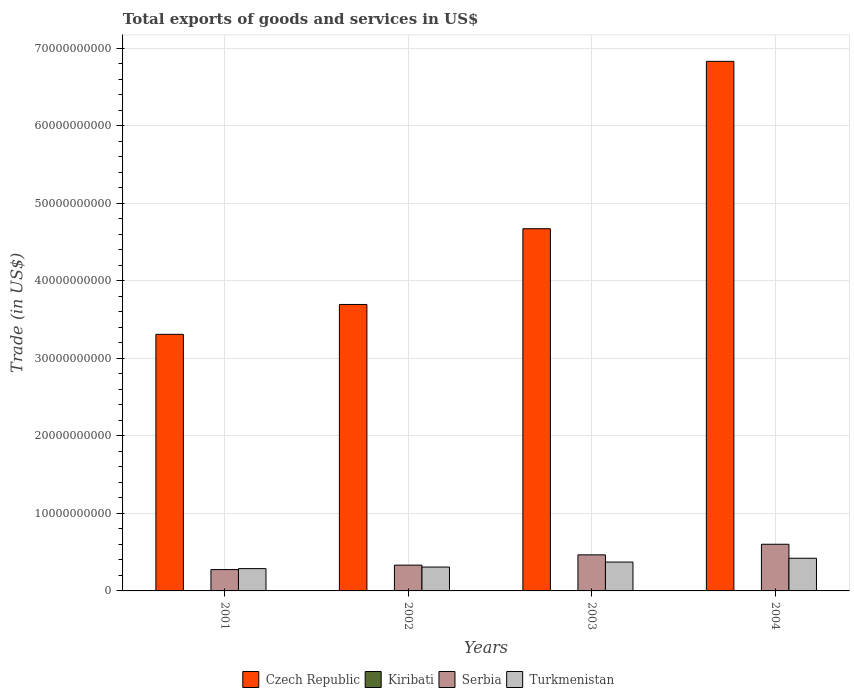Are the number of bars per tick equal to the number of legend labels?
Provide a short and direct response. Yes. How many bars are there on the 3rd tick from the left?
Your response must be concise. 4. How many bars are there on the 4th tick from the right?
Your response must be concise. 4. What is the label of the 1st group of bars from the left?
Make the answer very short. 2001. What is the total exports of goods and services in Czech Republic in 2003?
Provide a succinct answer. 4.67e+1. Across all years, what is the maximum total exports of goods and services in Czech Republic?
Provide a short and direct response. 6.83e+1. Across all years, what is the minimum total exports of goods and services in Serbia?
Give a very brief answer. 2.75e+09. In which year was the total exports of goods and services in Turkmenistan maximum?
Your response must be concise. 2004. In which year was the total exports of goods and services in Serbia minimum?
Offer a terse response. 2001. What is the total total exports of goods and services in Turkmenistan in the graph?
Offer a terse response. 1.39e+1. What is the difference between the total exports of goods and services in Serbia in 2002 and that in 2003?
Your response must be concise. -1.33e+09. What is the difference between the total exports of goods and services in Czech Republic in 2003 and the total exports of goods and services in Serbia in 2002?
Give a very brief answer. 4.34e+1. What is the average total exports of goods and services in Turkmenistan per year?
Provide a short and direct response. 3.47e+09. In the year 2004, what is the difference between the total exports of goods and services in Serbia and total exports of goods and services in Czech Republic?
Your answer should be compact. -6.23e+1. In how many years, is the total exports of goods and services in Turkmenistan greater than 32000000000 US$?
Provide a short and direct response. 0. What is the ratio of the total exports of goods and services in Turkmenistan in 2002 to that in 2004?
Offer a terse response. 0.73. What is the difference between the highest and the second highest total exports of goods and services in Czech Republic?
Your response must be concise. 2.16e+1. What is the difference between the highest and the lowest total exports of goods and services in Kiribati?
Your answer should be very brief. 4.78e+06. Is it the case that in every year, the sum of the total exports of goods and services in Czech Republic and total exports of goods and services in Turkmenistan is greater than the sum of total exports of goods and services in Serbia and total exports of goods and services in Kiribati?
Offer a terse response. No. What does the 2nd bar from the left in 2004 represents?
Your answer should be compact. Kiribati. What does the 3rd bar from the right in 2001 represents?
Offer a terse response. Kiribati. Is it the case that in every year, the sum of the total exports of goods and services in Turkmenistan and total exports of goods and services in Kiribati is greater than the total exports of goods and services in Serbia?
Offer a very short reply. No. How many bars are there?
Provide a succinct answer. 16. Are all the bars in the graph horizontal?
Offer a terse response. No. How many years are there in the graph?
Offer a very short reply. 4. What is the difference between two consecutive major ticks on the Y-axis?
Ensure brevity in your answer.  1.00e+1. Are the values on the major ticks of Y-axis written in scientific E-notation?
Offer a very short reply. No. Does the graph contain any zero values?
Your answer should be compact. No. How many legend labels are there?
Ensure brevity in your answer.  4. How are the legend labels stacked?
Offer a terse response. Horizontal. What is the title of the graph?
Your answer should be very brief. Total exports of goods and services in US$. What is the label or title of the X-axis?
Your answer should be compact. Years. What is the label or title of the Y-axis?
Provide a succinct answer. Trade (in US$). What is the Trade (in US$) of Czech Republic in 2001?
Ensure brevity in your answer.  3.31e+1. What is the Trade (in US$) of Kiribati in 2001?
Your answer should be compact. 1.01e+07. What is the Trade (in US$) of Serbia in 2001?
Ensure brevity in your answer.  2.75e+09. What is the Trade (in US$) in Turkmenistan in 2001?
Provide a succinct answer. 2.88e+09. What is the Trade (in US$) in Czech Republic in 2002?
Provide a succinct answer. 3.70e+1. What is the Trade (in US$) of Kiribati in 2002?
Your answer should be compact. 1.35e+07. What is the Trade (in US$) of Serbia in 2002?
Your answer should be compact. 3.33e+09. What is the Trade (in US$) of Turkmenistan in 2002?
Ensure brevity in your answer.  3.08e+09. What is the Trade (in US$) in Czech Republic in 2003?
Offer a terse response. 4.67e+1. What is the Trade (in US$) of Kiribati in 2003?
Give a very brief answer. 1.49e+07. What is the Trade (in US$) of Serbia in 2003?
Provide a short and direct response. 4.65e+09. What is the Trade (in US$) of Turkmenistan in 2003?
Ensure brevity in your answer.  3.72e+09. What is the Trade (in US$) in Czech Republic in 2004?
Your answer should be very brief. 6.83e+1. What is the Trade (in US$) of Kiribati in 2004?
Keep it short and to the point. 1.19e+07. What is the Trade (in US$) of Serbia in 2004?
Ensure brevity in your answer.  6.02e+09. What is the Trade (in US$) of Turkmenistan in 2004?
Keep it short and to the point. 4.22e+09. Across all years, what is the maximum Trade (in US$) in Czech Republic?
Your answer should be compact. 6.83e+1. Across all years, what is the maximum Trade (in US$) in Kiribati?
Provide a short and direct response. 1.49e+07. Across all years, what is the maximum Trade (in US$) in Serbia?
Offer a terse response. 6.02e+09. Across all years, what is the maximum Trade (in US$) of Turkmenistan?
Keep it short and to the point. 4.22e+09. Across all years, what is the minimum Trade (in US$) in Czech Republic?
Make the answer very short. 3.31e+1. Across all years, what is the minimum Trade (in US$) in Kiribati?
Provide a succinct answer. 1.01e+07. Across all years, what is the minimum Trade (in US$) in Serbia?
Your response must be concise. 2.75e+09. Across all years, what is the minimum Trade (in US$) in Turkmenistan?
Provide a short and direct response. 2.88e+09. What is the total Trade (in US$) of Czech Republic in the graph?
Your answer should be very brief. 1.85e+11. What is the total Trade (in US$) of Kiribati in the graph?
Your answer should be very brief. 5.04e+07. What is the total Trade (in US$) of Serbia in the graph?
Make the answer very short. 1.68e+1. What is the total Trade (in US$) of Turkmenistan in the graph?
Offer a very short reply. 1.39e+1. What is the difference between the Trade (in US$) of Czech Republic in 2001 and that in 2002?
Keep it short and to the point. -3.86e+09. What is the difference between the Trade (in US$) of Kiribati in 2001 and that in 2002?
Ensure brevity in your answer.  -3.36e+06. What is the difference between the Trade (in US$) of Serbia in 2001 and that in 2002?
Your response must be concise. -5.74e+08. What is the difference between the Trade (in US$) of Turkmenistan in 2001 and that in 2002?
Ensure brevity in your answer.  -2.04e+08. What is the difference between the Trade (in US$) of Czech Republic in 2001 and that in 2003?
Give a very brief answer. -1.36e+1. What is the difference between the Trade (in US$) in Kiribati in 2001 and that in 2003?
Your answer should be very brief. -4.78e+06. What is the difference between the Trade (in US$) of Serbia in 2001 and that in 2003?
Provide a succinct answer. -1.90e+09. What is the difference between the Trade (in US$) of Turkmenistan in 2001 and that in 2003?
Your response must be concise. -8.48e+08. What is the difference between the Trade (in US$) in Czech Republic in 2001 and that in 2004?
Your response must be concise. -3.52e+1. What is the difference between the Trade (in US$) of Kiribati in 2001 and that in 2004?
Your answer should be compact. -1.76e+06. What is the difference between the Trade (in US$) of Serbia in 2001 and that in 2004?
Offer a terse response. -3.27e+09. What is the difference between the Trade (in US$) in Turkmenistan in 2001 and that in 2004?
Keep it short and to the point. -1.34e+09. What is the difference between the Trade (in US$) in Czech Republic in 2002 and that in 2003?
Give a very brief answer. -9.77e+09. What is the difference between the Trade (in US$) in Kiribati in 2002 and that in 2003?
Ensure brevity in your answer.  -1.42e+06. What is the difference between the Trade (in US$) of Serbia in 2002 and that in 2003?
Your answer should be compact. -1.33e+09. What is the difference between the Trade (in US$) in Turkmenistan in 2002 and that in 2003?
Offer a terse response. -6.44e+08. What is the difference between the Trade (in US$) of Czech Republic in 2002 and that in 2004?
Your answer should be very brief. -3.14e+1. What is the difference between the Trade (in US$) in Kiribati in 2002 and that in 2004?
Provide a succinct answer. 1.60e+06. What is the difference between the Trade (in US$) in Serbia in 2002 and that in 2004?
Keep it short and to the point. -2.69e+09. What is the difference between the Trade (in US$) of Turkmenistan in 2002 and that in 2004?
Offer a very short reply. -1.14e+09. What is the difference between the Trade (in US$) in Czech Republic in 2003 and that in 2004?
Keep it short and to the point. -2.16e+1. What is the difference between the Trade (in US$) in Kiribati in 2003 and that in 2004?
Your response must be concise. 3.02e+06. What is the difference between the Trade (in US$) of Serbia in 2003 and that in 2004?
Your answer should be compact. -1.37e+09. What is the difference between the Trade (in US$) in Turkmenistan in 2003 and that in 2004?
Your answer should be compact. -4.92e+08. What is the difference between the Trade (in US$) in Czech Republic in 2001 and the Trade (in US$) in Kiribati in 2002?
Keep it short and to the point. 3.31e+1. What is the difference between the Trade (in US$) in Czech Republic in 2001 and the Trade (in US$) in Serbia in 2002?
Your answer should be compact. 2.98e+1. What is the difference between the Trade (in US$) of Czech Republic in 2001 and the Trade (in US$) of Turkmenistan in 2002?
Your answer should be compact. 3.00e+1. What is the difference between the Trade (in US$) of Kiribati in 2001 and the Trade (in US$) of Serbia in 2002?
Offer a very short reply. -3.32e+09. What is the difference between the Trade (in US$) of Kiribati in 2001 and the Trade (in US$) of Turkmenistan in 2002?
Your response must be concise. -3.07e+09. What is the difference between the Trade (in US$) of Serbia in 2001 and the Trade (in US$) of Turkmenistan in 2002?
Your response must be concise. -3.28e+08. What is the difference between the Trade (in US$) in Czech Republic in 2001 and the Trade (in US$) in Kiribati in 2003?
Offer a very short reply. 3.31e+1. What is the difference between the Trade (in US$) of Czech Republic in 2001 and the Trade (in US$) of Serbia in 2003?
Make the answer very short. 2.85e+1. What is the difference between the Trade (in US$) of Czech Republic in 2001 and the Trade (in US$) of Turkmenistan in 2003?
Offer a very short reply. 2.94e+1. What is the difference between the Trade (in US$) in Kiribati in 2001 and the Trade (in US$) in Serbia in 2003?
Offer a terse response. -4.64e+09. What is the difference between the Trade (in US$) in Kiribati in 2001 and the Trade (in US$) in Turkmenistan in 2003?
Your response must be concise. -3.71e+09. What is the difference between the Trade (in US$) of Serbia in 2001 and the Trade (in US$) of Turkmenistan in 2003?
Your answer should be compact. -9.71e+08. What is the difference between the Trade (in US$) of Czech Republic in 2001 and the Trade (in US$) of Kiribati in 2004?
Your response must be concise. 3.31e+1. What is the difference between the Trade (in US$) of Czech Republic in 2001 and the Trade (in US$) of Serbia in 2004?
Your answer should be very brief. 2.71e+1. What is the difference between the Trade (in US$) in Czech Republic in 2001 and the Trade (in US$) in Turkmenistan in 2004?
Your response must be concise. 2.89e+1. What is the difference between the Trade (in US$) of Kiribati in 2001 and the Trade (in US$) of Serbia in 2004?
Provide a short and direct response. -6.01e+09. What is the difference between the Trade (in US$) of Kiribati in 2001 and the Trade (in US$) of Turkmenistan in 2004?
Provide a short and direct response. -4.21e+09. What is the difference between the Trade (in US$) of Serbia in 2001 and the Trade (in US$) of Turkmenistan in 2004?
Provide a succinct answer. -1.46e+09. What is the difference between the Trade (in US$) of Czech Republic in 2002 and the Trade (in US$) of Kiribati in 2003?
Provide a short and direct response. 3.69e+1. What is the difference between the Trade (in US$) of Czech Republic in 2002 and the Trade (in US$) of Serbia in 2003?
Make the answer very short. 3.23e+1. What is the difference between the Trade (in US$) of Czech Republic in 2002 and the Trade (in US$) of Turkmenistan in 2003?
Offer a very short reply. 3.32e+1. What is the difference between the Trade (in US$) of Kiribati in 2002 and the Trade (in US$) of Serbia in 2003?
Your response must be concise. -4.64e+09. What is the difference between the Trade (in US$) of Kiribati in 2002 and the Trade (in US$) of Turkmenistan in 2003?
Make the answer very short. -3.71e+09. What is the difference between the Trade (in US$) of Serbia in 2002 and the Trade (in US$) of Turkmenistan in 2003?
Your response must be concise. -3.97e+08. What is the difference between the Trade (in US$) of Czech Republic in 2002 and the Trade (in US$) of Kiribati in 2004?
Give a very brief answer. 3.69e+1. What is the difference between the Trade (in US$) of Czech Republic in 2002 and the Trade (in US$) of Serbia in 2004?
Make the answer very short. 3.09e+1. What is the difference between the Trade (in US$) of Czech Republic in 2002 and the Trade (in US$) of Turkmenistan in 2004?
Make the answer very short. 3.27e+1. What is the difference between the Trade (in US$) in Kiribati in 2002 and the Trade (in US$) in Serbia in 2004?
Give a very brief answer. -6.01e+09. What is the difference between the Trade (in US$) in Kiribati in 2002 and the Trade (in US$) in Turkmenistan in 2004?
Keep it short and to the point. -4.20e+09. What is the difference between the Trade (in US$) of Serbia in 2002 and the Trade (in US$) of Turkmenistan in 2004?
Provide a short and direct response. -8.89e+08. What is the difference between the Trade (in US$) in Czech Republic in 2003 and the Trade (in US$) in Kiribati in 2004?
Offer a terse response. 4.67e+1. What is the difference between the Trade (in US$) in Czech Republic in 2003 and the Trade (in US$) in Serbia in 2004?
Keep it short and to the point. 4.07e+1. What is the difference between the Trade (in US$) of Czech Republic in 2003 and the Trade (in US$) of Turkmenistan in 2004?
Your response must be concise. 4.25e+1. What is the difference between the Trade (in US$) of Kiribati in 2003 and the Trade (in US$) of Serbia in 2004?
Make the answer very short. -6.01e+09. What is the difference between the Trade (in US$) of Kiribati in 2003 and the Trade (in US$) of Turkmenistan in 2004?
Your response must be concise. -4.20e+09. What is the difference between the Trade (in US$) of Serbia in 2003 and the Trade (in US$) of Turkmenistan in 2004?
Your answer should be very brief. 4.38e+08. What is the average Trade (in US$) of Czech Republic per year?
Your answer should be very brief. 4.63e+1. What is the average Trade (in US$) in Kiribati per year?
Make the answer very short. 1.26e+07. What is the average Trade (in US$) of Serbia per year?
Keep it short and to the point. 4.19e+09. What is the average Trade (in US$) in Turkmenistan per year?
Offer a very short reply. 3.47e+09. In the year 2001, what is the difference between the Trade (in US$) in Czech Republic and Trade (in US$) in Kiribati?
Give a very brief answer. 3.31e+1. In the year 2001, what is the difference between the Trade (in US$) in Czech Republic and Trade (in US$) in Serbia?
Keep it short and to the point. 3.04e+1. In the year 2001, what is the difference between the Trade (in US$) in Czech Republic and Trade (in US$) in Turkmenistan?
Give a very brief answer. 3.02e+1. In the year 2001, what is the difference between the Trade (in US$) in Kiribati and Trade (in US$) in Serbia?
Your response must be concise. -2.74e+09. In the year 2001, what is the difference between the Trade (in US$) in Kiribati and Trade (in US$) in Turkmenistan?
Keep it short and to the point. -2.87e+09. In the year 2001, what is the difference between the Trade (in US$) of Serbia and Trade (in US$) of Turkmenistan?
Give a very brief answer. -1.24e+08. In the year 2002, what is the difference between the Trade (in US$) of Czech Republic and Trade (in US$) of Kiribati?
Ensure brevity in your answer.  3.69e+1. In the year 2002, what is the difference between the Trade (in US$) in Czech Republic and Trade (in US$) in Serbia?
Ensure brevity in your answer.  3.36e+1. In the year 2002, what is the difference between the Trade (in US$) in Czech Republic and Trade (in US$) in Turkmenistan?
Offer a terse response. 3.39e+1. In the year 2002, what is the difference between the Trade (in US$) in Kiribati and Trade (in US$) in Serbia?
Give a very brief answer. -3.31e+09. In the year 2002, what is the difference between the Trade (in US$) of Kiribati and Trade (in US$) of Turkmenistan?
Provide a succinct answer. -3.07e+09. In the year 2002, what is the difference between the Trade (in US$) of Serbia and Trade (in US$) of Turkmenistan?
Offer a very short reply. 2.46e+08. In the year 2003, what is the difference between the Trade (in US$) of Czech Republic and Trade (in US$) of Kiribati?
Offer a very short reply. 4.67e+1. In the year 2003, what is the difference between the Trade (in US$) in Czech Republic and Trade (in US$) in Serbia?
Your response must be concise. 4.21e+1. In the year 2003, what is the difference between the Trade (in US$) in Czech Republic and Trade (in US$) in Turkmenistan?
Give a very brief answer. 4.30e+1. In the year 2003, what is the difference between the Trade (in US$) in Kiribati and Trade (in US$) in Serbia?
Your answer should be very brief. -4.64e+09. In the year 2003, what is the difference between the Trade (in US$) in Kiribati and Trade (in US$) in Turkmenistan?
Ensure brevity in your answer.  -3.71e+09. In the year 2003, what is the difference between the Trade (in US$) of Serbia and Trade (in US$) of Turkmenistan?
Offer a terse response. 9.29e+08. In the year 2004, what is the difference between the Trade (in US$) in Czech Republic and Trade (in US$) in Kiribati?
Ensure brevity in your answer.  6.83e+1. In the year 2004, what is the difference between the Trade (in US$) in Czech Republic and Trade (in US$) in Serbia?
Keep it short and to the point. 6.23e+1. In the year 2004, what is the difference between the Trade (in US$) in Czech Republic and Trade (in US$) in Turkmenistan?
Offer a very short reply. 6.41e+1. In the year 2004, what is the difference between the Trade (in US$) in Kiribati and Trade (in US$) in Serbia?
Your response must be concise. -6.01e+09. In the year 2004, what is the difference between the Trade (in US$) in Kiribati and Trade (in US$) in Turkmenistan?
Make the answer very short. -4.20e+09. In the year 2004, what is the difference between the Trade (in US$) in Serbia and Trade (in US$) in Turkmenistan?
Keep it short and to the point. 1.81e+09. What is the ratio of the Trade (in US$) in Czech Republic in 2001 to that in 2002?
Your response must be concise. 0.9. What is the ratio of the Trade (in US$) in Kiribati in 2001 to that in 2002?
Provide a succinct answer. 0.75. What is the ratio of the Trade (in US$) in Serbia in 2001 to that in 2002?
Ensure brevity in your answer.  0.83. What is the ratio of the Trade (in US$) in Turkmenistan in 2001 to that in 2002?
Offer a terse response. 0.93. What is the ratio of the Trade (in US$) of Czech Republic in 2001 to that in 2003?
Give a very brief answer. 0.71. What is the ratio of the Trade (in US$) in Kiribati in 2001 to that in 2003?
Keep it short and to the point. 0.68. What is the ratio of the Trade (in US$) in Serbia in 2001 to that in 2003?
Ensure brevity in your answer.  0.59. What is the ratio of the Trade (in US$) of Turkmenistan in 2001 to that in 2003?
Offer a very short reply. 0.77. What is the ratio of the Trade (in US$) of Czech Republic in 2001 to that in 2004?
Keep it short and to the point. 0.48. What is the ratio of the Trade (in US$) in Kiribati in 2001 to that in 2004?
Provide a short and direct response. 0.85. What is the ratio of the Trade (in US$) in Serbia in 2001 to that in 2004?
Give a very brief answer. 0.46. What is the ratio of the Trade (in US$) of Turkmenistan in 2001 to that in 2004?
Ensure brevity in your answer.  0.68. What is the ratio of the Trade (in US$) of Czech Republic in 2002 to that in 2003?
Offer a terse response. 0.79. What is the ratio of the Trade (in US$) in Kiribati in 2002 to that in 2003?
Your response must be concise. 0.9. What is the ratio of the Trade (in US$) in Serbia in 2002 to that in 2003?
Offer a very short reply. 0.71. What is the ratio of the Trade (in US$) in Turkmenistan in 2002 to that in 2003?
Make the answer very short. 0.83. What is the ratio of the Trade (in US$) of Czech Republic in 2002 to that in 2004?
Keep it short and to the point. 0.54. What is the ratio of the Trade (in US$) in Kiribati in 2002 to that in 2004?
Make the answer very short. 1.13. What is the ratio of the Trade (in US$) in Serbia in 2002 to that in 2004?
Your response must be concise. 0.55. What is the ratio of the Trade (in US$) of Turkmenistan in 2002 to that in 2004?
Your response must be concise. 0.73. What is the ratio of the Trade (in US$) of Czech Republic in 2003 to that in 2004?
Your answer should be compact. 0.68. What is the ratio of the Trade (in US$) of Kiribati in 2003 to that in 2004?
Keep it short and to the point. 1.25. What is the ratio of the Trade (in US$) in Serbia in 2003 to that in 2004?
Offer a terse response. 0.77. What is the ratio of the Trade (in US$) of Turkmenistan in 2003 to that in 2004?
Offer a very short reply. 0.88. What is the difference between the highest and the second highest Trade (in US$) in Czech Republic?
Your answer should be very brief. 2.16e+1. What is the difference between the highest and the second highest Trade (in US$) in Kiribati?
Your answer should be compact. 1.42e+06. What is the difference between the highest and the second highest Trade (in US$) of Serbia?
Offer a terse response. 1.37e+09. What is the difference between the highest and the second highest Trade (in US$) in Turkmenistan?
Keep it short and to the point. 4.92e+08. What is the difference between the highest and the lowest Trade (in US$) in Czech Republic?
Provide a succinct answer. 3.52e+1. What is the difference between the highest and the lowest Trade (in US$) of Kiribati?
Provide a short and direct response. 4.78e+06. What is the difference between the highest and the lowest Trade (in US$) of Serbia?
Make the answer very short. 3.27e+09. What is the difference between the highest and the lowest Trade (in US$) of Turkmenistan?
Provide a succinct answer. 1.34e+09. 